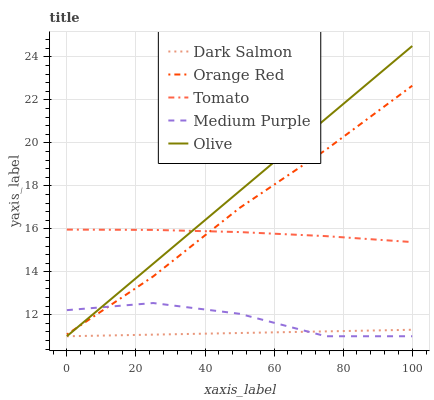Does Dark Salmon have the minimum area under the curve?
Answer yes or no. Yes. Does Olive have the maximum area under the curve?
Answer yes or no. Yes. Does Medium Purple have the minimum area under the curve?
Answer yes or no. No. Does Medium Purple have the maximum area under the curve?
Answer yes or no. No. Is Dark Salmon the smoothest?
Answer yes or no. Yes. Is Medium Purple the roughest?
Answer yes or no. Yes. Is Olive the smoothest?
Answer yes or no. No. Is Olive the roughest?
Answer yes or no. No. Does Medium Purple have the lowest value?
Answer yes or no. Yes. Does Orange Red have the lowest value?
Answer yes or no. No. Does Olive have the highest value?
Answer yes or no. Yes. Does Medium Purple have the highest value?
Answer yes or no. No. Is Dark Salmon less than Orange Red?
Answer yes or no. Yes. Is Tomato greater than Dark Salmon?
Answer yes or no. Yes. Does Dark Salmon intersect Medium Purple?
Answer yes or no. Yes. Is Dark Salmon less than Medium Purple?
Answer yes or no. No. Is Dark Salmon greater than Medium Purple?
Answer yes or no. No. Does Dark Salmon intersect Orange Red?
Answer yes or no. No. 